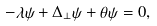Convert formula to latex. <formula><loc_0><loc_0><loc_500><loc_500>- \lambda \psi + \Delta _ { \perp } \psi + \theta \psi = 0 ,</formula> 